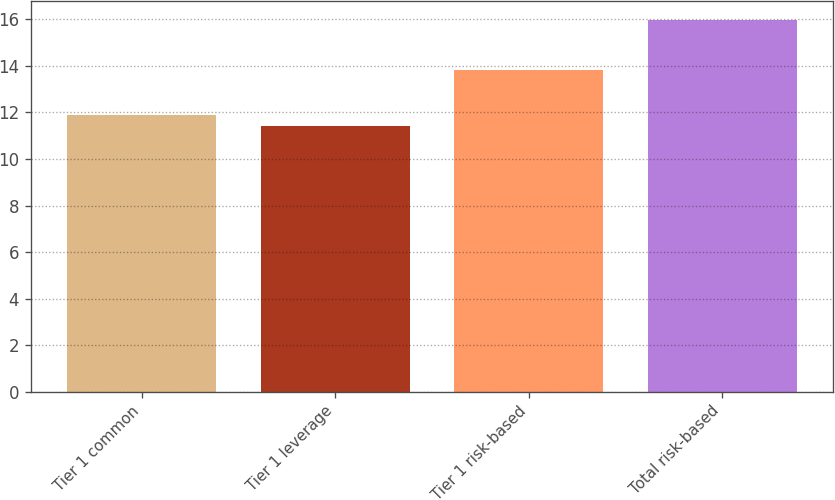Convert chart to OTSL. <chart><loc_0><loc_0><loc_500><loc_500><bar_chart><fcel>Tier 1 common<fcel>Tier 1 leverage<fcel>Tier 1 risk-based<fcel>Total risk-based<nl><fcel>11.88<fcel>11.43<fcel>13.84<fcel>15.98<nl></chart> 